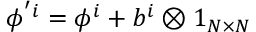<formula> <loc_0><loc_0><loc_500><loc_500>\phi ^ { ^ { \prime } i } = \phi ^ { i } + b ^ { i } \otimes 1 _ { N \times N }</formula> 